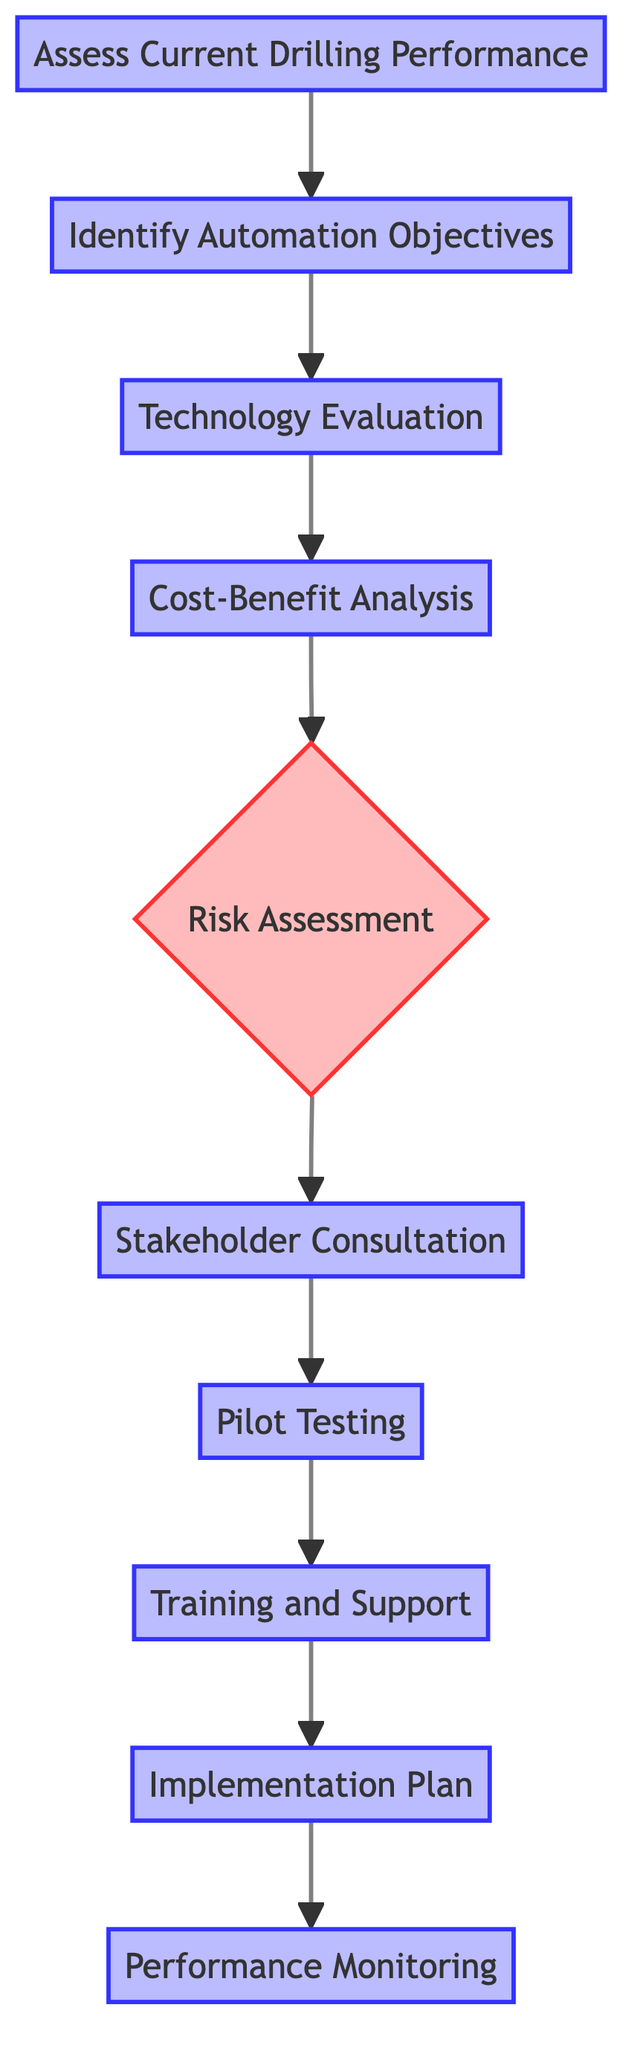What is the first step in the decision-making process? The first node in the flow chart is "Assess Current Drilling Performance," which initiates the decision-making process.
Answer: Assess Current Drilling Performance How many nodes are in the flow chart? Counting the individual boxes in the flow chart, there are 10 distinct nodes, each representing a step in the process.
Answer: 10 Which step follows the "Cost-Benefit Analysis"? According to the flow, after "Cost-Benefit Analysis," the next step is "Risk Assessment."
Answer: Risk Assessment What is the last step in the process? The flow chart shows that the final node is "Performance Monitoring," which is the last step of the decision-making process.
Answer: Performance Monitoring What is the decision point in the flow? The diagram indicates that "Risk Assessment" serves as the decision point within the overall flow of the process.
Answer: Risk Assessment Which two steps are directly linked to "Pilot Testing"? Both "Stakeholder Consultation" and "Training and Support" lead directly to "Pilot Testing," indicating a sequential flow from each of these steps to testing.
Answer: Stakeholder Consultation, Training and Support Which step comes immediately after "Pilot Testing"? The flow continues from "Pilot Testing" to the next step, which is "Training and Support."
Answer: Training and Support How does "Technology Evaluation" relate to "Identify Automation Objectives"? "Technology Evaluation" is the step that directly follows "Identify Automation Objectives," forming a sequential relationship between the two.
Answer: Directly follows How many steps involve consultation or training? The steps indicating consultation or training are "Stakeholder Consultation" and "Training and Support," totaling two steps specifically related to these activities.
Answer: 2 What is the focus of the "Cost-Benefit Analysis"? The focus of "Cost-Benefit Analysis" is to conduct a financial comparison between automated drilling and manual methods, evaluating investments versus benefits.
Answer: Financial comparison 